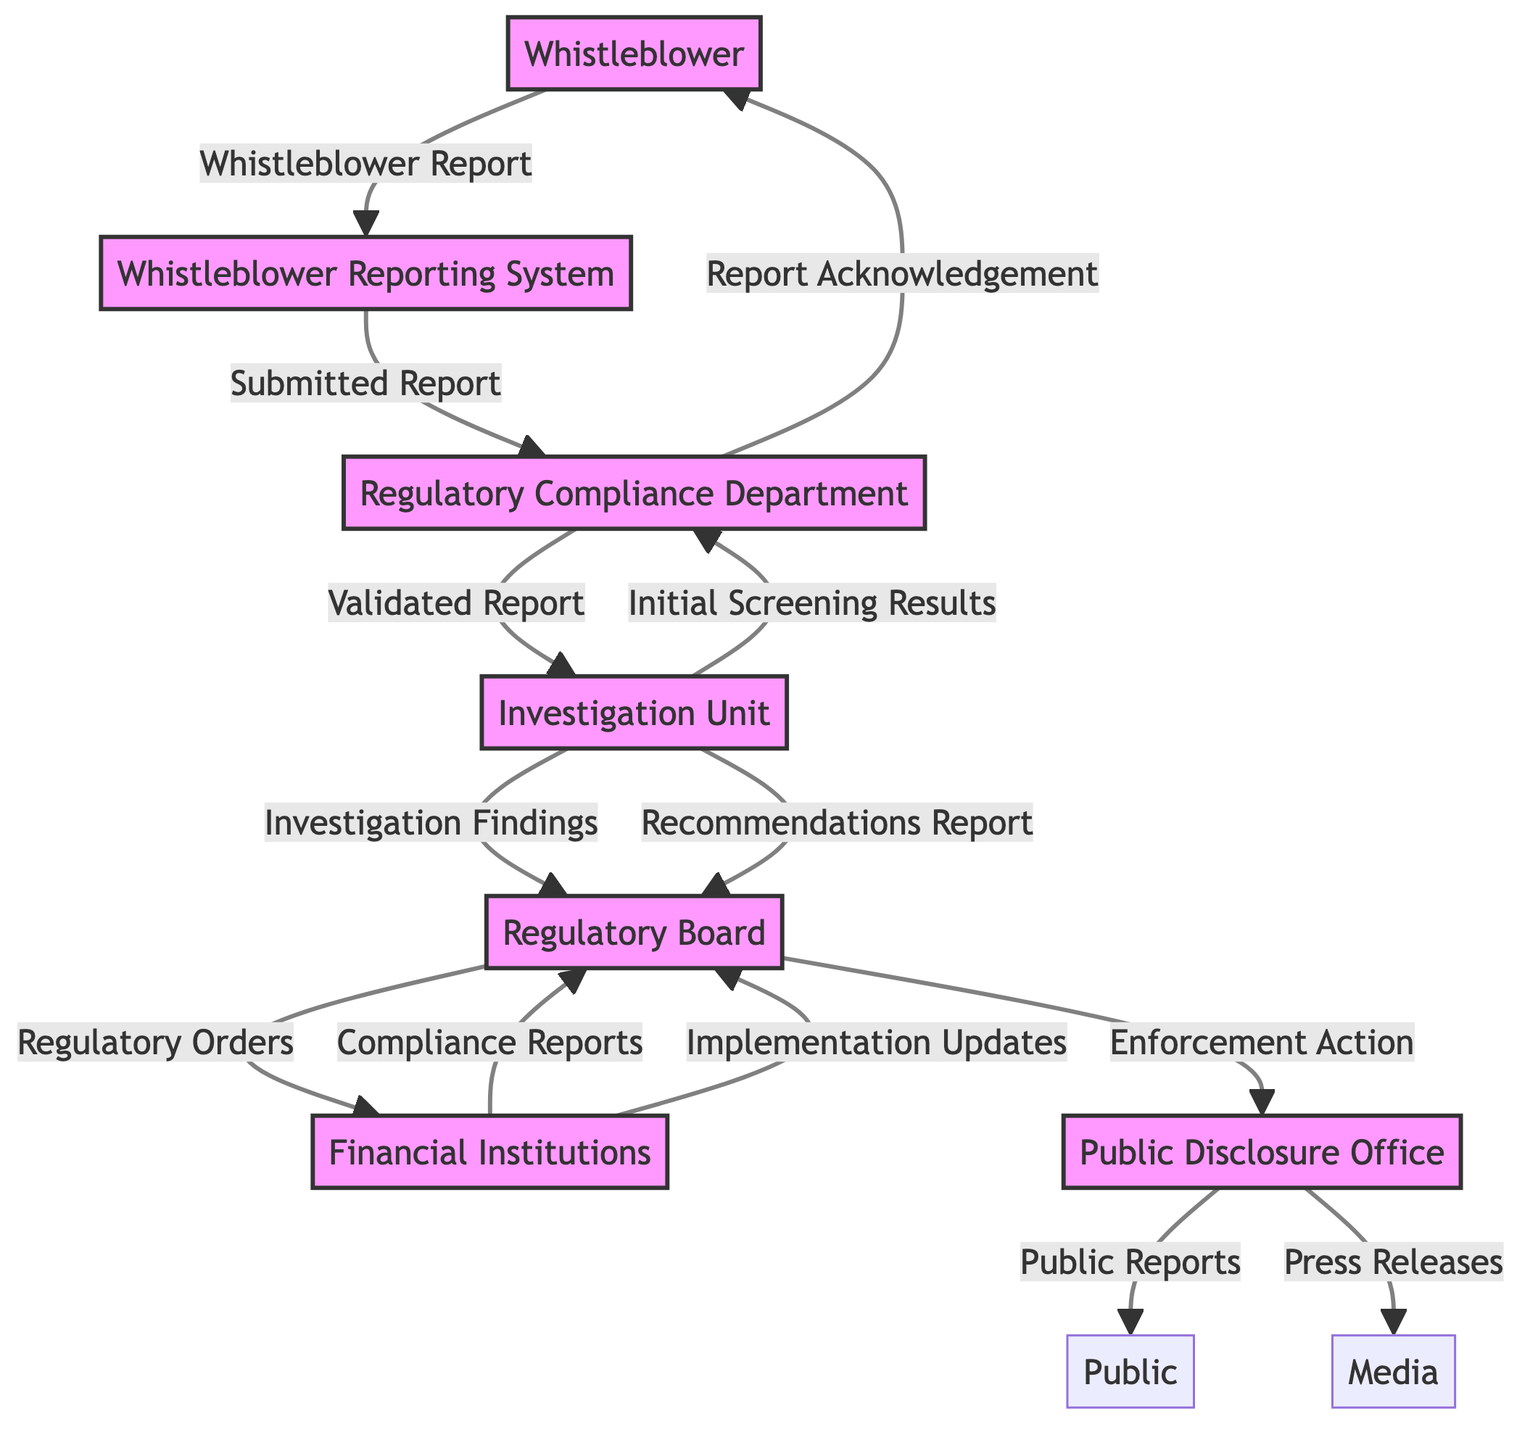What is the input to the Whistleblower Reporting System? The input to the Whistleblower Reporting System is the "Whistleblower Report" that comes from the Whistleblower.
Answer: Whistleblower Report How many outputs does the Regulatory Board have? The Regulatory Board produces two outputs: "Enforcement Action" and "Regulatory Orders." Therefore, the total number of outputs is 2.
Answer: 2 Which entity receives "Validated Report" as an input? The "Validated Report" is sent to the Investigation Unit from the Regulatory Compliance Department, making the Investigation Unit the receiver of this input.
Answer: Investigation Unit What is the first step after a Whistleblower submits a report? After the Whistleblower submits a report, the first step is the Regulatory Compliance Department receiving the "Submitted Report" to assess and validate it.
Answer: Regulatory Compliance Department What does the Public Disclosure Office output after receiving "Enforcement Action"? Upon receiving "Enforcement Action," the Public Disclosure Office outputs "Public Reports" and "Press Releases."
Answer: Public Reports, Press Releases Which entity reports handling "Compliance Reports"? The Financial Institutions send "Compliance Reports" to the Regulatory Board, indicating that the Regulatory Board handles these reports.
Answer: Regulatory Board What two documents does the Investigation Unit provide to the Regulatory Board? The Investigation Unit provides two key documents: "Investigation Findings" and "Recommendations Report" to the Regulatory Board for review.
Answer: Investigation Findings, Recommendations Report Which entity acknowledges the report to the Whistleblower? The Regulatory Compliance Department acknowledges the report that is submitted by the Whistleblower, confirming the receipt of the report.
Answer: Regulatory Compliance Department What is the output generated by the Whistleblower? The output generated by the Whistleblower is the "Whistleblower Report," which they submit through the Whistleblower Reporting System.
Answer: Whistleblower Report 